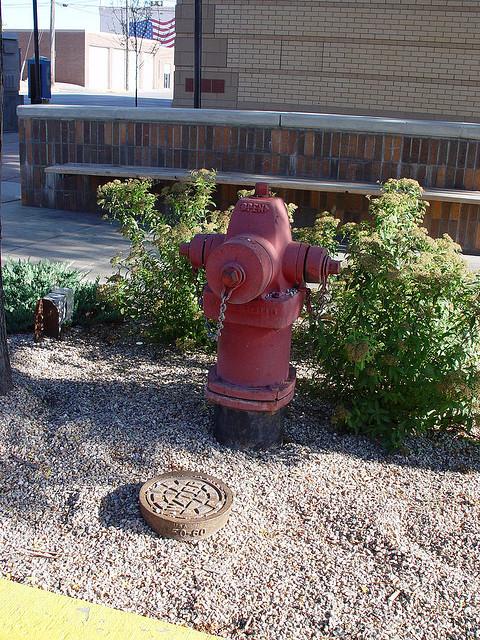What color is the building?
Answer briefly. Brown. What is a fire hydrant used for?
Give a very brief answer. Water. What is sitting next to the hydrant?
Short answer required. Bush. 